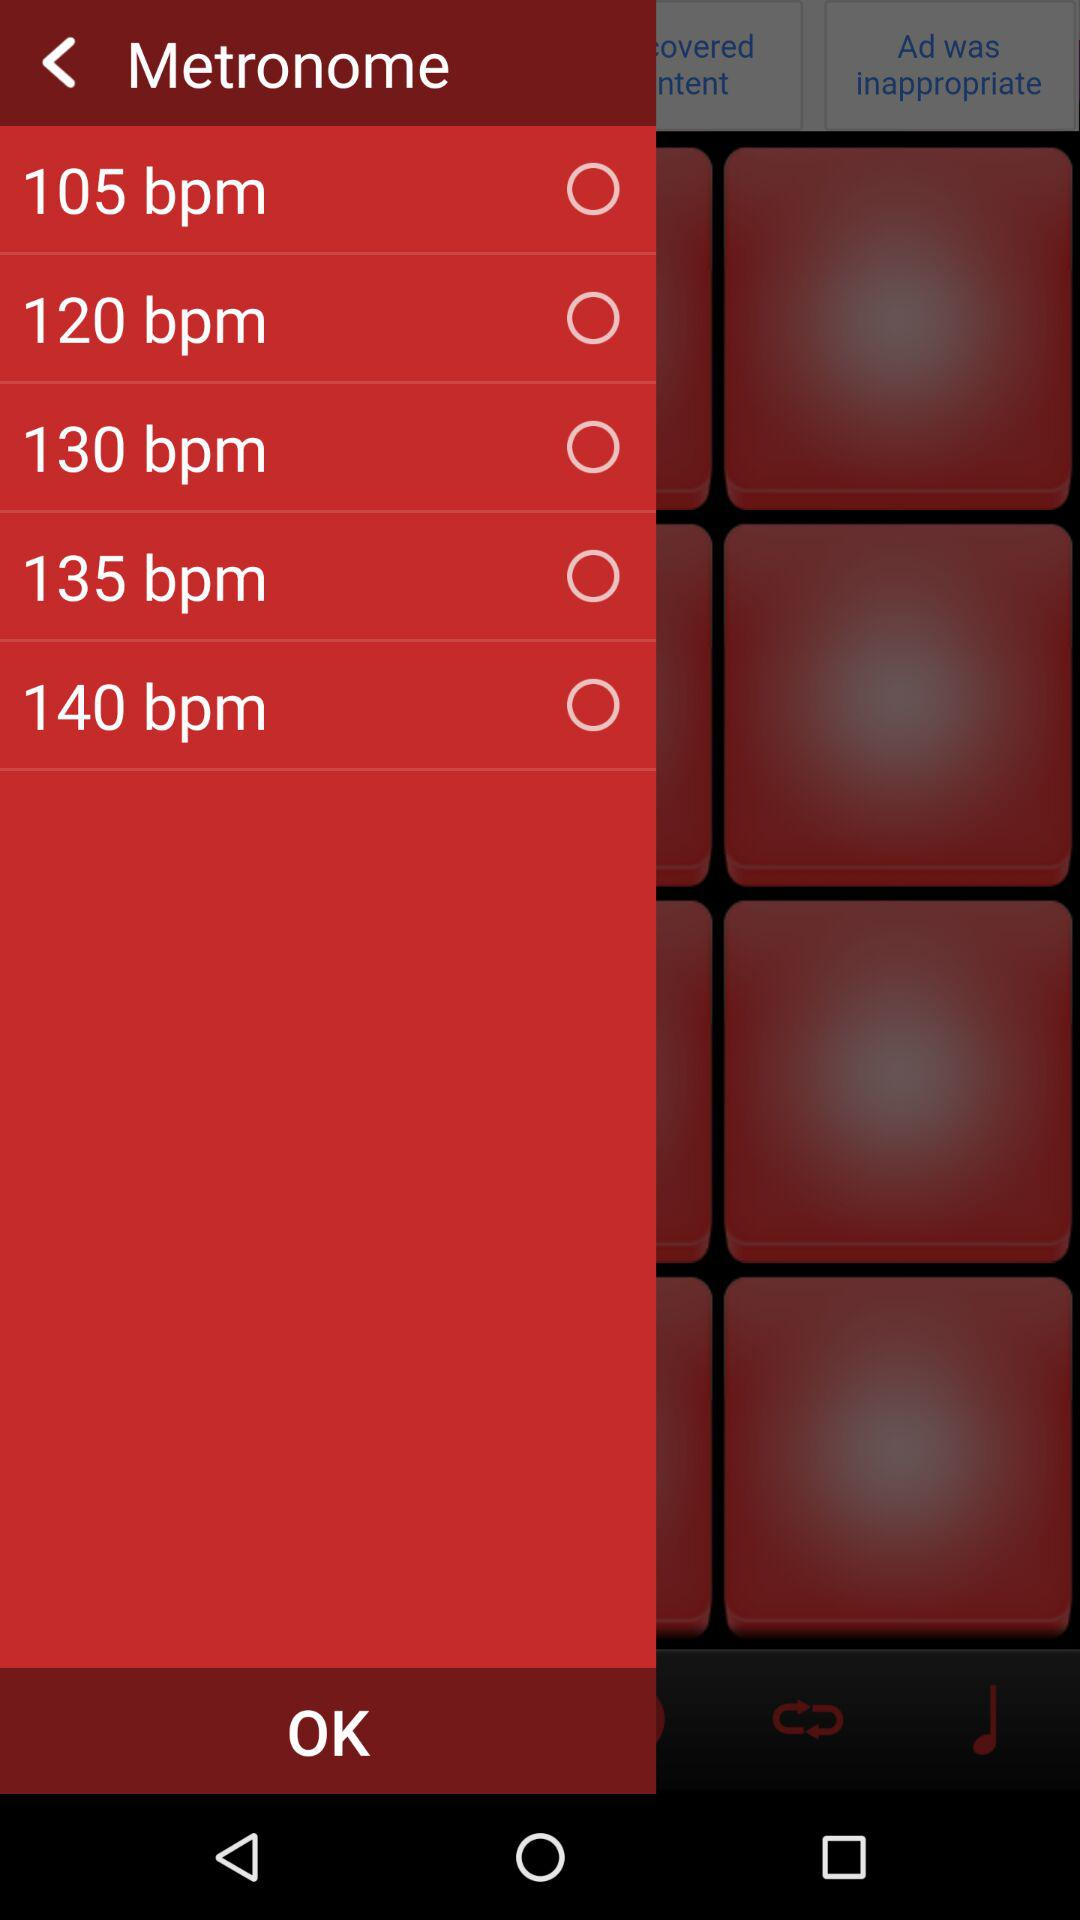How many of the bpm options are odd numbers?
Answer the question using a single word or phrase. 2 